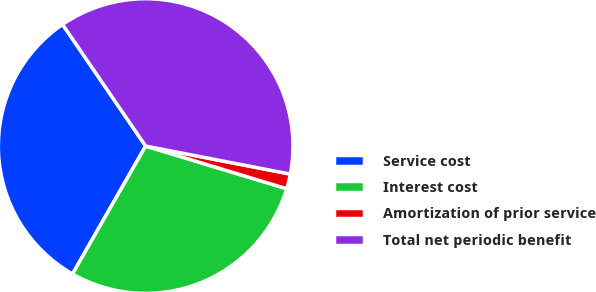Convert chart. <chart><loc_0><loc_0><loc_500><loc_500><pie_chart><fcel>Service cost<fcel>Interest cost<fcel>Amortization of prior service<fcel>Total net periodic benefit<nl><fcel>32.19%<fcel>28.59%<fcel>1.63%<fcel>37.58%<nl></chart> 